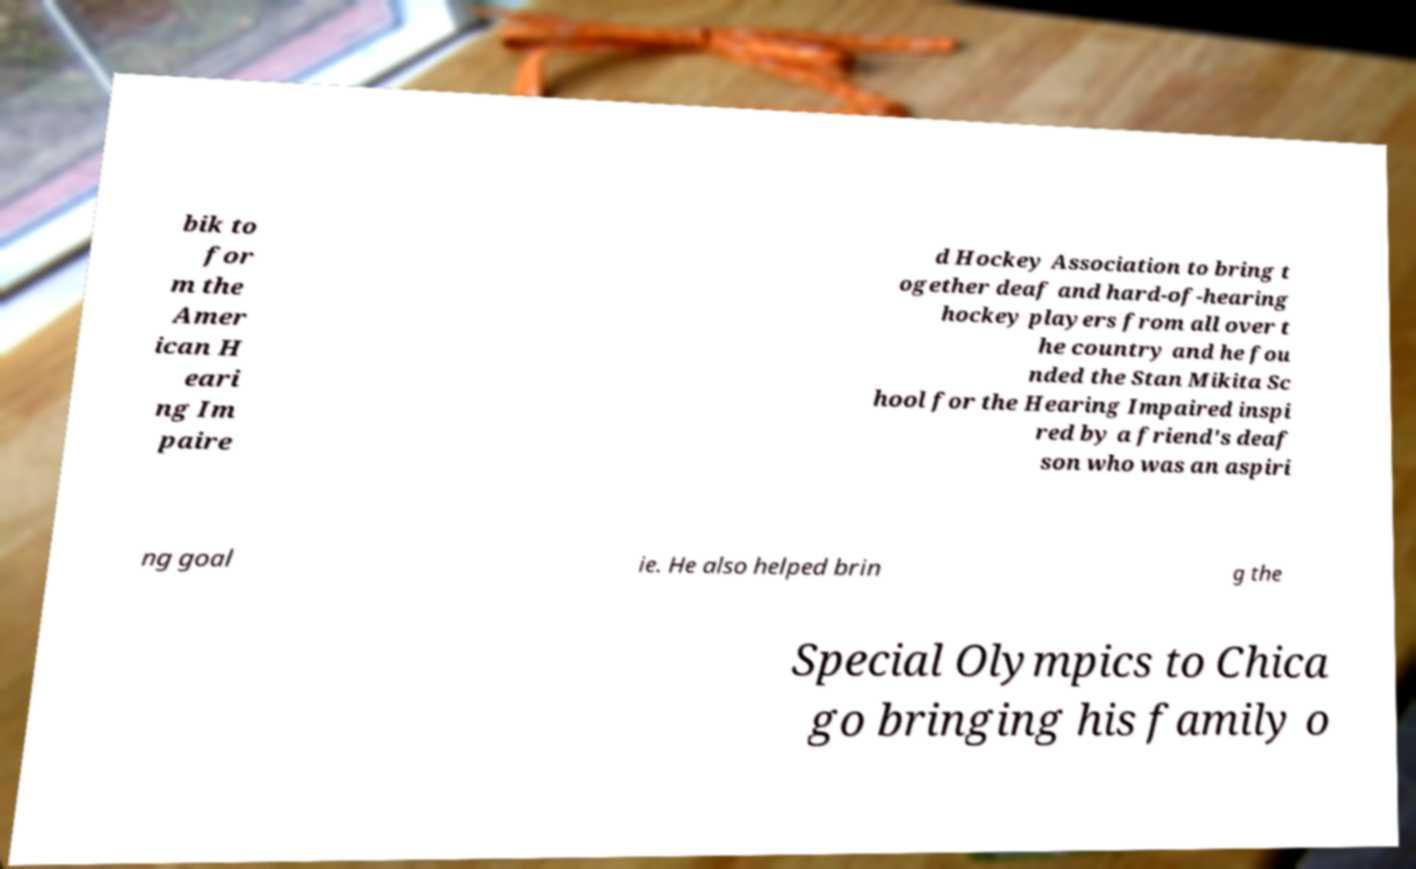Can you accurately transcribe the text from the provided image for me? bik to for m the Amer ican H eari ng Im paire d Hockey Association to bring t ogether deaf and hard-of-hearing hockey players from all over t he country and he fou nded the Stan Mikita Sc hool for the Hearing Impaired inspi red by a friend's deaf son who was an aspiri ng goal ie. He also helped brin g the Special Olympics to Chica go bringing his family o 